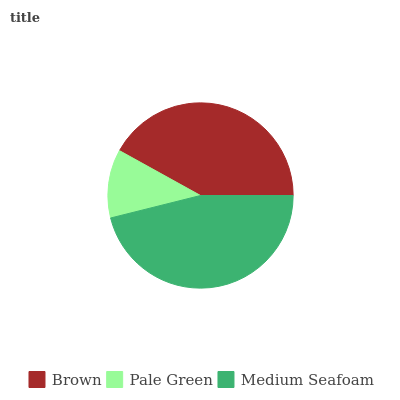Is Pale Green the minimum?
Answer yes or no. Yes. Is Medium Seafoam the maximum?
Answer yes or no. Yes. Is Medium Seafoam the minimum?
Answer yes or no. No. Is Pale Green the maximum?
Answer yes or no. No. Is Medium Seafoam greater than Pale Green?
Answer yes or no. Yes. Is Pale Green less than Medium Seafoam?
Answer yes or no. Yes. Is Pale Green greater than Medium Seafoam?
Answer yes or no. No. Is Medium Seafoam less than Pale Green?
Answer yes or no. No. Is Brown the high median?
Answer yes or no. Yes. Is Brown the low median?
Answer yes or no. Yes. Is Medium Seafoam the high median?
Answer yes or no. No. Is Medium Seafoam the low median?
Answer yes or no. No. 